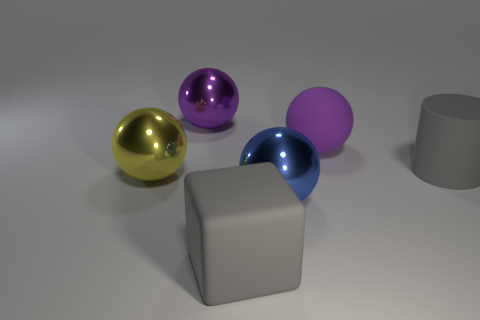How many objects are large objects that are behind the big yellow metal ball or big purple rubber spheres behind the yellow object?
Keep it short and to the point. 3. There is a gray cylinder that is the same size as the blue metallic ball; what is its material?
Give a very brief answer. Rubber. What number of other objects are the same material as the gray block?
Give a very brief answer. 2. There is a purple metal object behind the large rubber ball; is its shape the same as the gray thing to the right of the big blue metallic ball?
Your answer should be very brief. No. There is a metallic object that is in front of the big metallic ball that is left of the sphere behind the large purple matte object; what is its color?
Ensure brevity in your answer.  Blue. What number of other objects are the same color as the matte cylinder?
Provide a succinct answer. 1. Is the number of small gray metallic things less than the number of big cubes?
Provide a short and direct response. Yes. There is a ball that is both behind the rubber cylinder and left of the big rubber ball; what color is it?
Provide a short and direct response. Purple. There is another big purple object that is the same shape as the purple metallic thing; what is it made of?
Your response must be concise. Rubber. Is the number of large purple rubber balls greater than the number of small purple spheres?
Make the answer very short. Yes. 